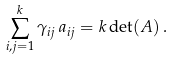<formula> <loc_0><loc_0><loc_500><loc_500>\sum _ { i , j = 1 } ^ { k } \gamma _ { i j } \, a _ { i j } = k \det ( A ) \, .</formula> 